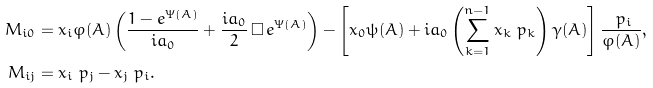<formula> <loc_0><loc_0><loc_500><loc_500>M _ { i 0 } & = x _ { i } \varphi ( A ) \left ( \frac { 1 - e ^ { \Psi ( A ) } } { i a _ { 0 } } + \frac { i a _ { 0 } } { 2 } \, \square \, e ^ { \Psi ( A ) } \right ) - \left [ x _ { 0 } \psi ( A ) + i a _ { 0 } \left ( \sum _ { k = 1 } ^ { n - 1 } x _ { k } \ p _ { k } \right ) \gamma ( A ) \right ] \frac { \ p _ { i } } { \varphi ( A ) } , \\ M _ { i j } & = x _ { i } \ p _ { j } - x _ { j } \ p _ { i } .</formula> 